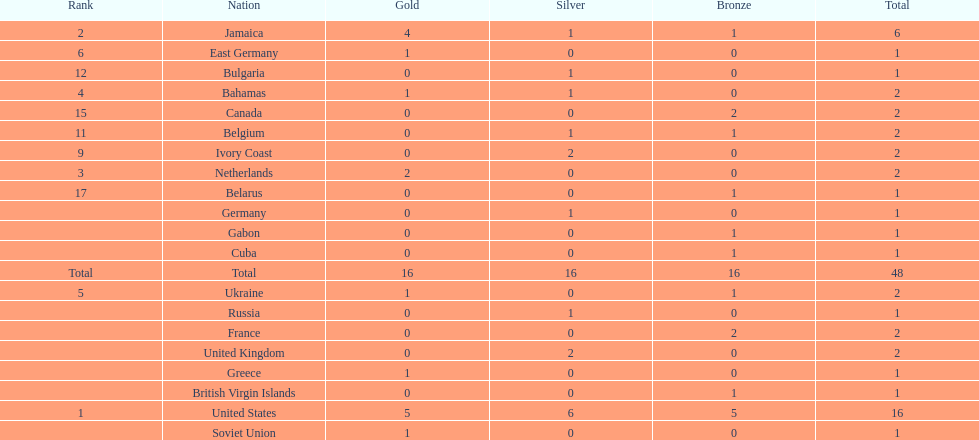What is the total number of gold medals won by jamaica? 4. 